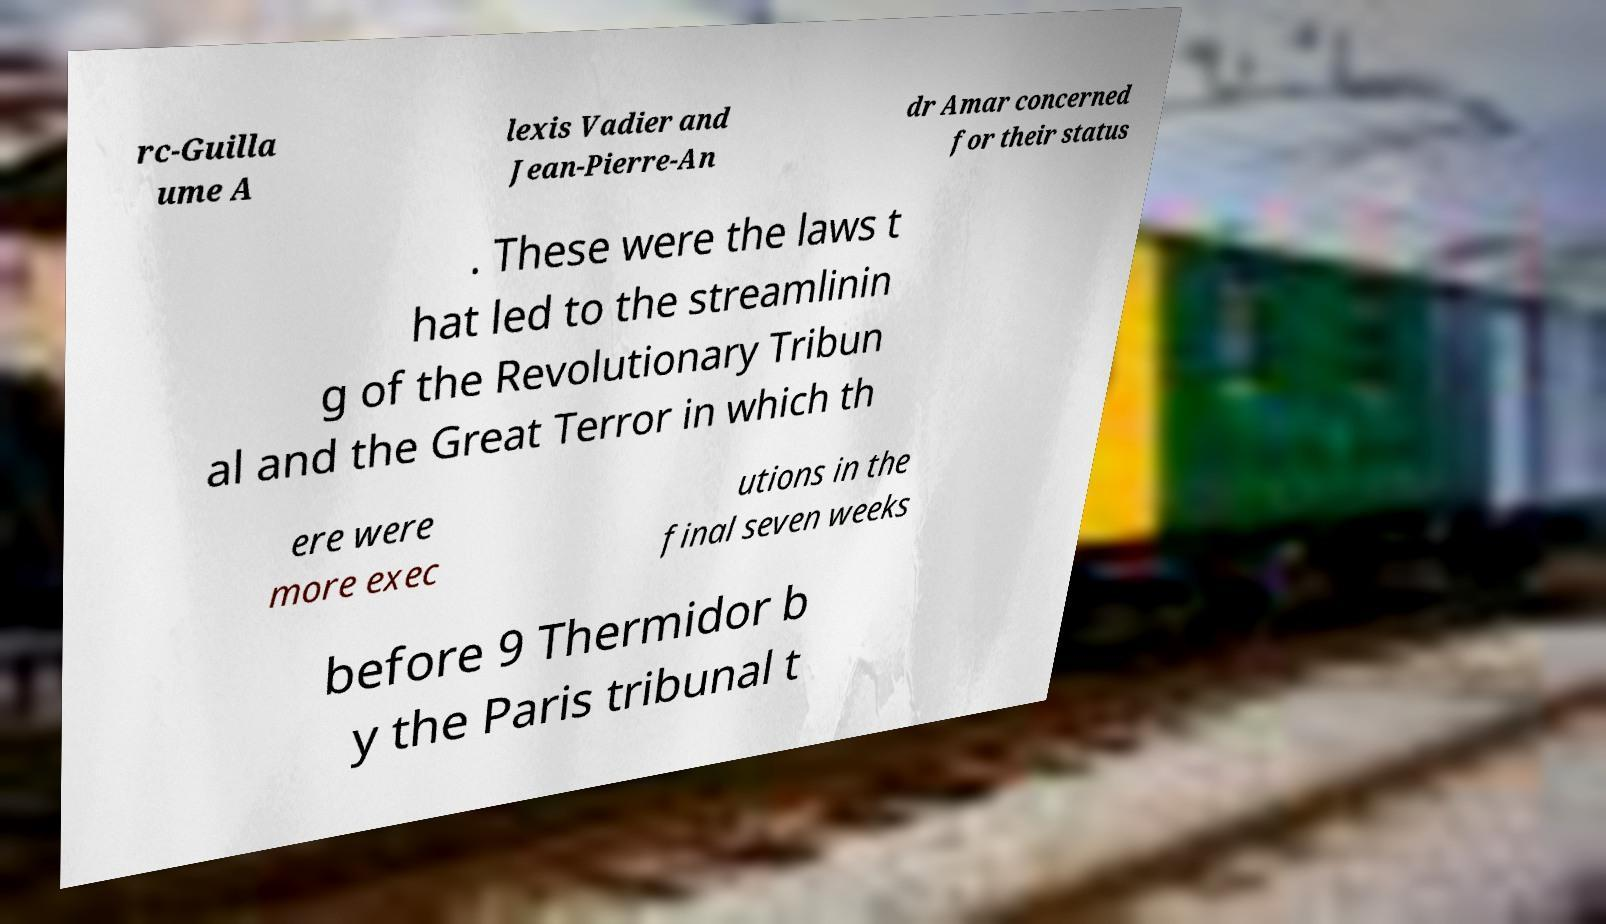There's text embedded in this image that I need extracted. Can you transcribe it verbatim? rc-Guilla ume A lexis Vadier and Jean-Pierre-An dr Amar concerned for their status . These were the laws t hat led to the streamlinin g of the Revolutionary Tribun al and the Great Terror in which th ere were more exec utions in the final seven weeks before 9 Thermidor b y the Paris tribunal t 